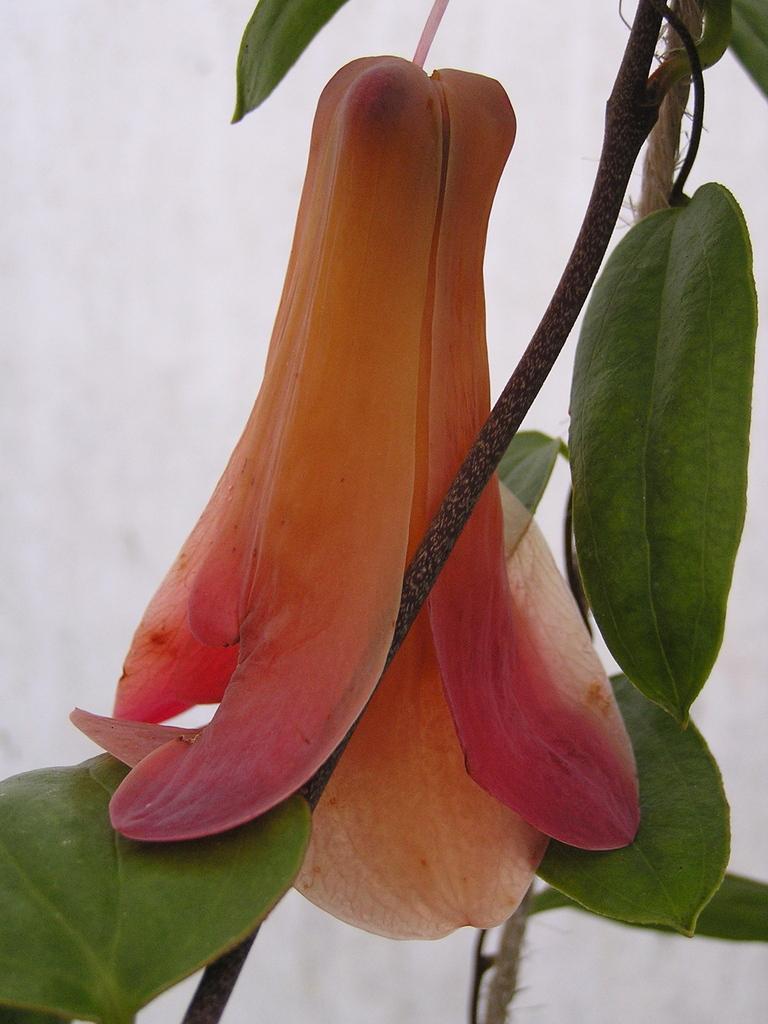Please provide a concise description of this image. In this picture we can see a flower, stem and leaves. In the background, the image is not clear. 